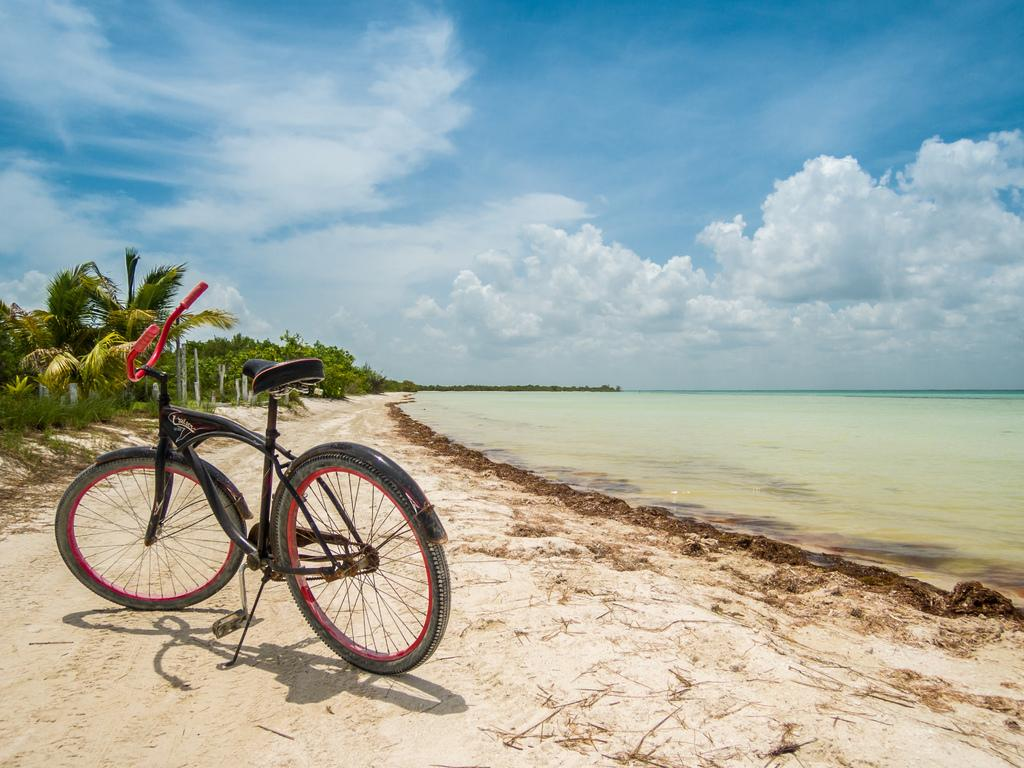What is the main mode of transportation in the image? There is a cycle in the image. What type of natural landscape is visible on the right side of the image? There is a sea shore on the right side of the image. What type of vegetation is on the left side of the image? There are trees on the left side of the image. What is visible in the background of the image? There is sky visible in the background of the image. What can be seen in the sky? Clouds are present in the sky. What type of kite is being flown by the crowd on the sea shore in the image? There is no kite or crowd present in the image; it features a cycle and natural landscapes. What type of polish is being applied to the cycle in the image? There is no indication of polish or any maintenance activity being performed on the cycle in the image. 